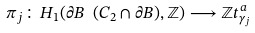<formula> <loc_0><loc_0><loc_500><loc_500>\pi _ { j } \colon H _ { 1 } ( \partial B \ ( C _ { 2 } \cap \partial B ) , \mathbb { Z } ) \longrightarrow \mathbb { Z } t _ { \gamma _ { j } } ^ { a }</formula> 